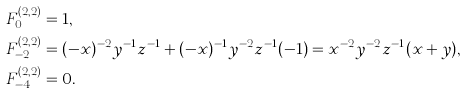Convert formula to latex. <formula><loc_0><loc_0><loc_500><loc_500>F _ { 0 } ^ { ( 2 , 2 ) } & = 1 , \\ F _ { - 2 } ^ { ( 2 , 2 ) } & = ( - x ) ^ { - 2 } y ^ { - 1 } z ^ { - 1 } + ( - x ) ^ { - 1 } y ^ { - 2 } z ^ { - 1 } ( - 1 ) = x ^ { - 2 } y ^ { - 2 } z ^ { - 1 } ( x + y ) , \\ F _ { - 4 } ^ { ( 2 , 2 ) } & = 0 .</formula> 